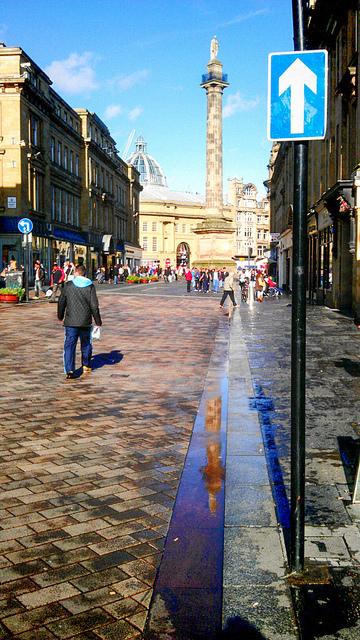Is there a statue in the photo?
Concise answer only. Yes. Is the ground wet or dry?
Be succinct. Wet. What is the weather forecast in the picture?
Concise answer only. Sunny. What symbol is on the closest sign?
Quick response, please. Arrow. 